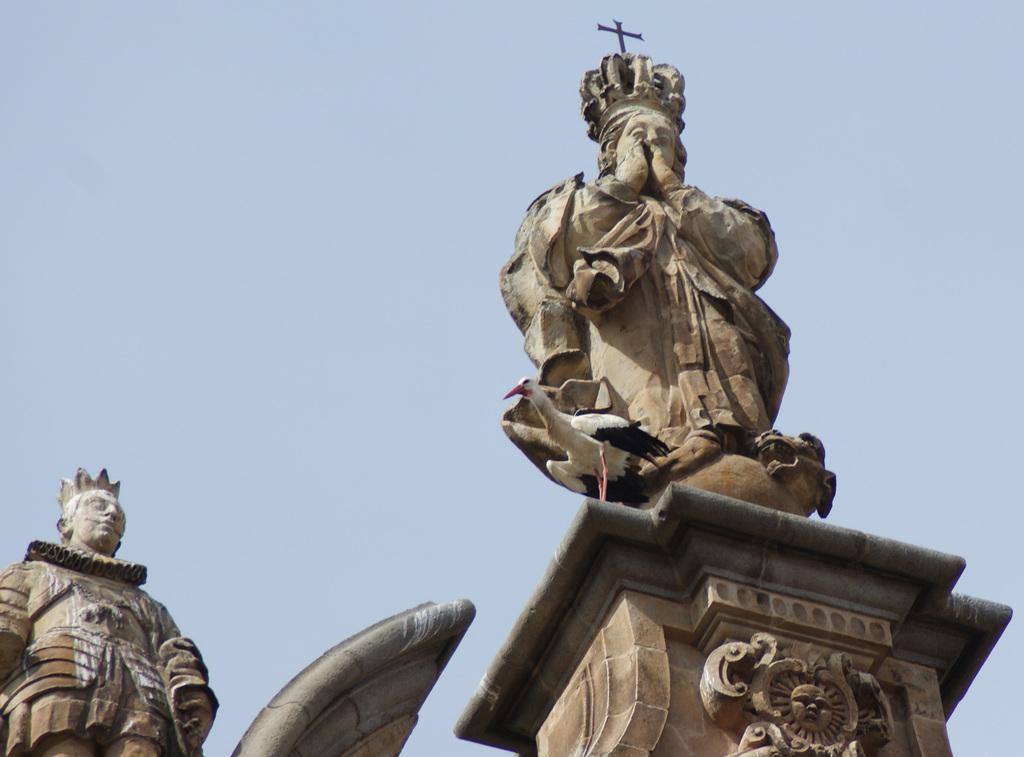How many statues are present in the image? There are two statues in the image. What else can be seen in the image besides the statues? There is a bird on a pillar in the image. What is visible in the background of the image? The sky is visible in the background of the image. What request does the bird make to the statues in the image? There is no indication in the image that the bird is making any requests to the statues, as birds do not communicate in this manner. 